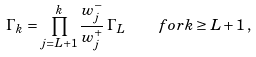<formula> <loc_0><loc_0><loc_500><loc_500>\Gamma _ { k } = \prod _ { j = L + 1 } ^ { k } \frac { w ^ { - } _ { j } } { w ^ { + } _ { j } } \, \Gamma _ { L } \quad f o r k \geq L + 1 \, ,</formula> 